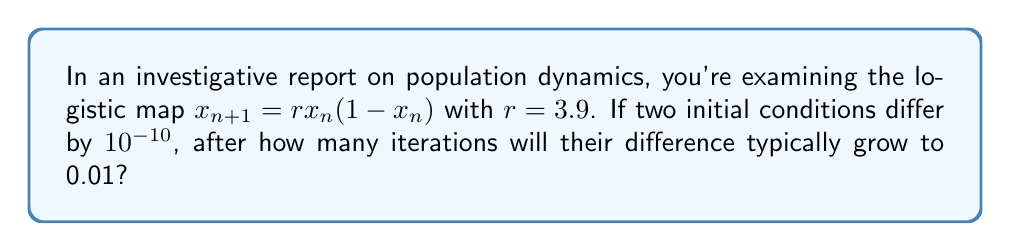What is the answer to this math problem? To solve this problem, we need to understand the concept of Lyapunov exponent and how it relates to the sensitivity of initial conditions in chaotic systems.

1) The Lyapunov exponent ($\lambda$) for the logistic map with $r=3.9$ is approximately 0.6346.

2) The Lyapunov exponent tells us how quickly nearby trajectories diverge. If two initial conditions differ by $\delta_0$, after $n$ iterations, their difference $\delta_n$ is approximately:

   $$\delta_n \approx \delta_0 e^{\lambda n}$$

3) We're given $\delta_0 = 10^{-10}$ and we want to find $n$ when $\delta_n = 0.01$. Let's substitute these into the equation:

   $$0.01 \approx 10^{-10} e^{0.6346n}$$

4) Now, let's solve for $n$:
   
   $$e^{0.6346n} \approx \frac{0.01}{10^{-10}} = 10^8$$

5) Taking the natural log of both sides:

   $$0.6346n \approx \ln(10^8) = 8\ln(10) \approx 18.4207$$

6) Solving for $n$:

   $$n \approx \frac{18.4207}{0.6346} \approx 29.0273$$

7) Since we need a whole number of iterations, we round up to 30.
Answer: 30 iterations 